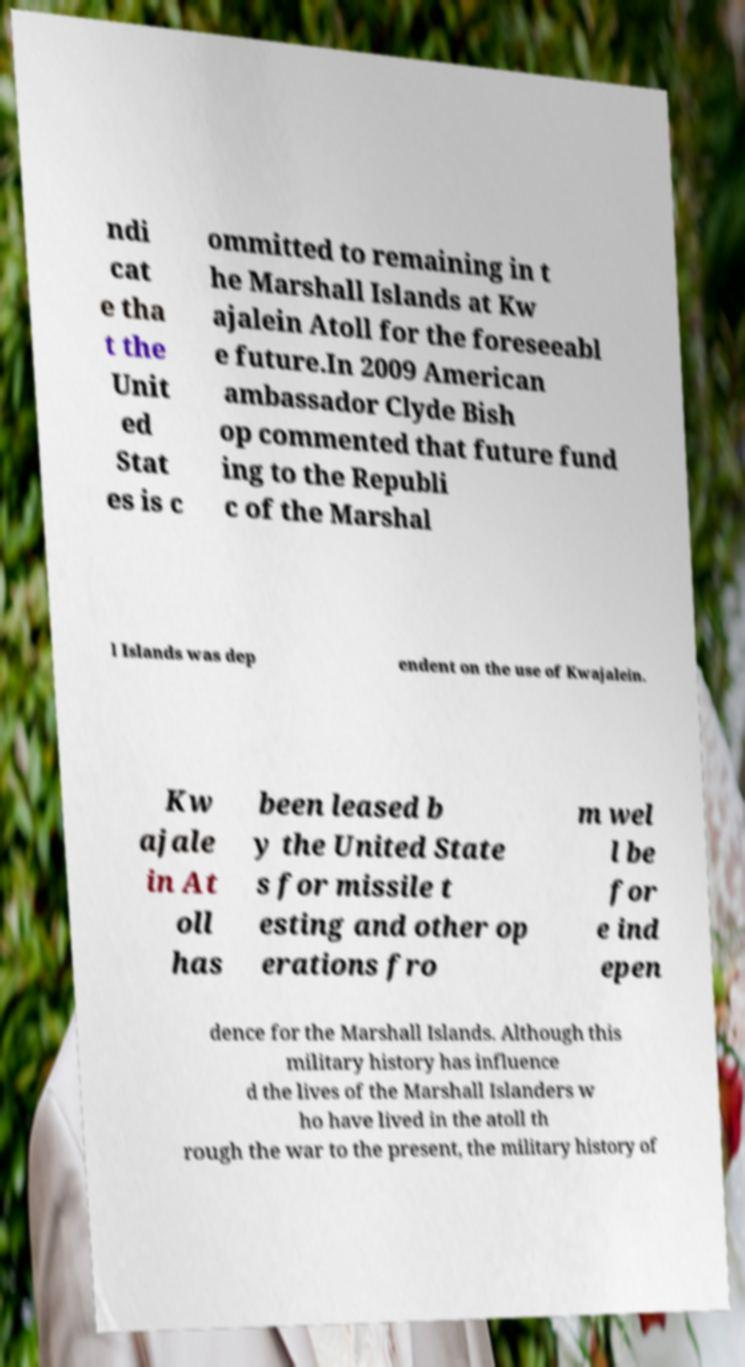Please read and relay the text visible in this image. What does it say? ndi cat e tha t the Unit ed Stat es is c ommitted to remaining in t he Marshall Islands at Kw ajalein Atoll for the foreseeabl e future.In 2009 American ambassador Clyde Bish op commented that future fund ing to the Republi c of the Marshal l Islands was dep endent on the use of Kwajalein. Kw ajale in At oll has been leased b y the United State s for missile t esting and other op erations fro m wel l be for e ind epen dence for the Marshall Islands. Although this military history has influence d the lives of the Marshall Islanders w ho have lived in the atoll th rough the war to the present, the military history of 